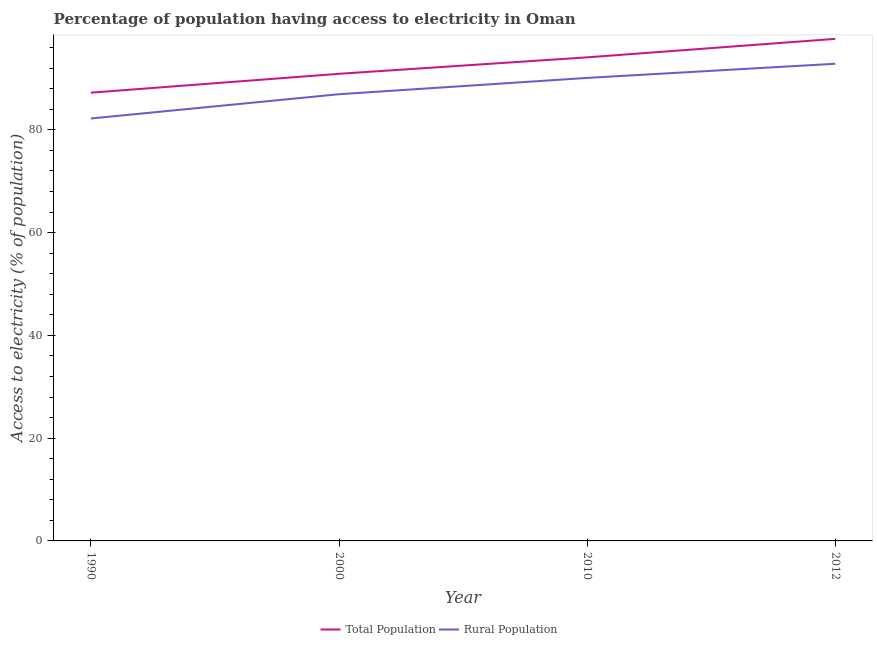How many different coloured lines are there?
Keep it short and to the point. 2. What is the percentage of rural population having access to electricity in 2012?
Your response must be concise. 92.85. Across all years, what is the maximum percentage of population having access to electricity?
Ensure brevity in your answer.  97.7. Across all years, what is the minimum percentage of rural population having access to electricity?
Offer a very short reply. 82.2. What is the total percentage of population having access to electricity in the graph?
Your response must be concise. 369.92. What is the difference between the percentage of rural population having access to electricity in 1990 and that in 2010?
Your answer should be very brief. -7.9. What is the difference between the percentage of rural population having access to electricity in 2010 and the percentage of population having access to electricity in 2012?
Ensure brevity in your answer.  -7.6. What is the average percentage of population having access to electricity per year?
Offer a terse response. 92.48. In the year 1990, what is the difference between the percentage of population having access to electricity and percentage of rural population having access to electricity?
Offer a terse response. 5.02. In how many years, is the percentage of rural population having access to electricity greater than 32 %?
Offer a very short reply. 4. What is the ratio of the percentage of rural population having access to electricity in 1990 to that in 2010?
Keep it short and to the point. 0.91. What is the difference between the highest and the second highest percentage of rural population having access to electricity?
Keep it short and to the point. 2.75. What is the difference between the highest and the lowest percentage of population having access to electricity?
Offer a terse response. 10.47. Is the percentage of rural population having access to electricity strictly greater than the percentage of population having access to electricity over the years?
Offer a terse response. No. Is the percentage of population having access to electricity strictly less than the percentage of rural population having access to electricity over the years?
Your answer should be very brief. No. How many lines are there?
Make the answer very short. 2. How many years are there in the graph?
Keep it short and to the point. 4. What is the difference between two consecutive major ticks on the Y-axis?
Provide a succinct answer. 20. Does the graph contain any zero values?
Your answer should be compact. No. Does the graph contain grids?
Your answer should be very brief. No. Where does the legend appear in the graph?
Offer a terse response. Bottom center. What is the title of the graph?
Keep it short and to the point. Percentage of population having access to electricity in Oman. What is the label or title of the X-axis?
Your answer should be compact. Year. What is the label or title of the Y-axis?
Offer a very short reply. Access to electricity (% of population). What is the Access to electricity (% of population) in Total Population in 1990?
Provide a succinct answer. 87.23. What is the Access to electricity (% of population) of Rural Population in 1990?
Your response must be concise. 82.2. What is the Access to electricity (% of population) in Total Population in 2000?
Your answer should be very brief. 90.9. What is the Access to electricity (% of population) in Rural Population in 2000?
Offer a very short reply. 86.93. What is the Access to electricity (% of population) in Total Population in 2010?
Provide a short and direct response. 94.1. What is the Access to electricity (% of population) of Rural Population in 2010?
Give a very brief answer. 90.1. What is the Access to electricity (% of population) in Total Population in 2012?
Offer a terse response. 97.7. What is the Access to electricity (% of population) in Rural Population in 2012?
Keep it short and to the point. 92.85. Across all years, what is the maximum Access to electricity (% of population) in Total Population?
Your answer should be very brief. 97.7. Across all years, what is the maximum Access to electricity (% of population) of Rural Population?
Make the answer very short. 92.85. Across all years, what is the minimum Access to electricity (% of population) in Total Population?
Provide a succinct answer. 87.23. Across all years, what is the minimum Access to electricity (% of population) of Rural Population?
Make the answer very short. 82.2. What is the total Access to electricity (% of population) in Total Population in the graph?
Give a very brief answer. 369.92. What is the total Access to electricity (% of population) in Rural Population in the graph?
Your answer should be very brief. 352.08. What is the difference between the Access to electricity (% of population) of Total Population in 1990 and that in 2000?
Give a very brief answer. -3.67. What is the difference between the Access to electricity (% of population) in Rural Population in 1990 and that in 2000?
Give a very brief answer. -4.72. What is the difference between the Access to electricity (% of population) of Total Population in 1990 and that in 2010?
Keep it short and to the point. -6.87. What is the difference between the Access to electricity (% of population) in Rural Population in 1990 and that in 2010?
Your response must be concise. -7.9. What is the difference between the Access to electricity (% of population) of Total Population in 1990 and that in 2012?
Provide a succinct answer. -10.47. What is the difference between the Access to electricity (% of population) in Rural Population in 1990 and that in 2012?
Your answer should be very brief. -10.65. What is the difference between the Access to electricity (% of population) in Total Population in 2000 and that in 2010?
Give a very brief answer. -3.2. What is the difference between the Access to electricity (% of population) in Rural Population in 2000 and that in 2010?
Your answer should be compact. -3.17. What is the difference between the Access to electricity (% of population) of Total Population in 2000 and that in 2012?
Ensure brevity in your answer.  -6.8. What is the difference between the Access to electricity (% of population) in Rural Population in 2000 and that in 2012?
Your answer should be compact. -5.93. What is the difference between the Access to electricity (% of population) of Total Population in 2010 and that in 2012?
Make the answer very short. -3.6. What is the difference between the Access to electricity (% of population) of Rural Population in 2010 and that in 2012?
Provide a succinct answer. -2.75. What is the difference between the Access to electricity (% of population) in Total Population in 1990 and the Access to electricity (% of population) in Rural Population in 2000?
Provide a succinct answer. 0.3. What is the difference between the Access to electricity (% of population) of Total Population in 1990 and the Access to electricity (% of population) of Rural Population in 2010?
Give a very brief answer. -2.87. What is the difference between the Access to electricity (% of population) in Total Population in 1990 and the Access to electricity (% of population) in Rural Population in 2012?
Your answer should be compact. -5.63. What is the difference between the Access to electricity (% of population) of Total Population in 2000 and the Access to electricity (% of population) of Rural Population in 2010?
Your answer should be very brief. 0.8. What is the difference between the Access to electricity (% of population) in Total Population in 2000 and the Access to electricity (% of population) in Rural Population in 2012?
Provide a short and direct response. -1.96. What is the difference between the Access to electricity (% of population) of Total Population in 2010 and the Access to electricity (% of population) of Rural Population in 2012?
Your answer should be very brief. 1.25. What is the average Access to electricity (% of population) in Total Population per year?
Offer a terse response. 92.48. What is the average Access to electricity (% of population) in Rural Population per year?
Offer a very short reply. 88.02. In the year 1990, what is the difference between the Access to electricity (% of population) of Total Population and Access to electricity (% of population) of Rural Population?
Give a very brief answer. 5.02. In the year 2000, what is the difference between the Access to electricity (% of population) in Total Population and Access to electricity (% of population) in Rural Population?
Provide a succinct answer. 3.97. In the year 2012, what is the difference between the Access to electricity (% of population) of Total Population and Access to electricity (% of population) of Rural Population?
Provide a short and direct response. 4.84. What is the ratio of the Access to electricity (% of population) in Total Population in 1990 to that in 2000?
Provide a succinct answer. 0.96. What is the ratio of the Access to electricity (% of population) of Rural Population in 1990 to that in 2000?
Your answer should be compact. 0.95. What is the ratio of the Access to electricity (% of population) in Total Population in 1990 to that in 2010?
Offer a very short reply. 0.93. What is the ratio of the Access to electricity (% of population) in Rural Population in 1990 to that in 2010?
Provide a short and direct response. 0.91. What is the ratio of the Access to electricity (% of population) of Total Population in 1990 to that in 2012?
Offer a terse response. 0.89. What is the ratio of the Access to electricity (% of population) of Rural Population in 1990 to that in 2012?
Make the answer very short. 0.89. What is the ratio of the Access to electricity (% of population) of Total Population in 2000 to that in 2010?
Keep it short and to the point. 0.97. What is the ratio of the Access to electricity (% of population) in Rural Population in 2000 to that in 2010?
Keep it short and to the point. 0.96. What is the ratio of the Access to electricity (% of population) of Total Population in 2000 to that in 2012?
Offer a very short reply. 0.93. What is the ratio of the Access to electricity (% of population) of Rural Population in 2000 to that in 2012?
Your answer should be compact. 0.94. What is the ratio of the Access to electricity (% of population) of Total Population in 2010 to that in 2012?
Provide a short and direct response. 0.96. What is the ratio of the Access to electricity (% of population) in Rural Population in 2010 to that in 2012?
Make the answer very short. 0.97. What is the difference between the highest and the second highest Access to electricity (% of population) of Total Population?
Ensure brevity in your answer.  3.6. What is the difference between the highest and the second highest Access to electricity (% of population) in Rural Population?
Provide a short and direct response. 2.75. What is the difference between the highest and the lowest Access to electricity (% of population) in Total Population?
Your answer should be very brief. 10.47. What is the difference between the highest and the lowest Access to electricity (% of population) in Rural Population?
Provide a short and direct response. 10.65. 